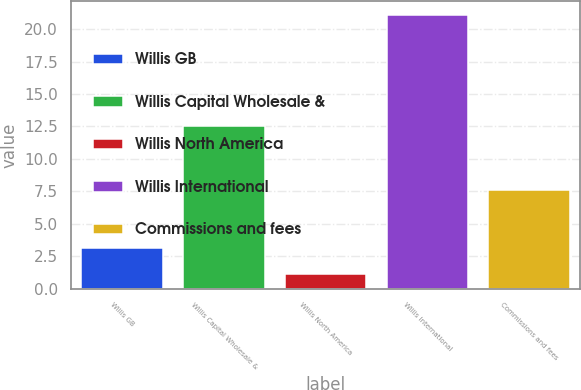Convert chart to OTSL. <chart><loc_0><loc_0><loc_500><loc_500><bar_chart><fcel>Willis GB<fcel>Willis Capital Wholesale &<fcel>Willis North America<fcel>Willis International<fcel>Commissions and fees<nl><fcel>3.1<fcel>12.5<fcel>1.1<fcel>21.1<fcel>7.6<nl></chart> 